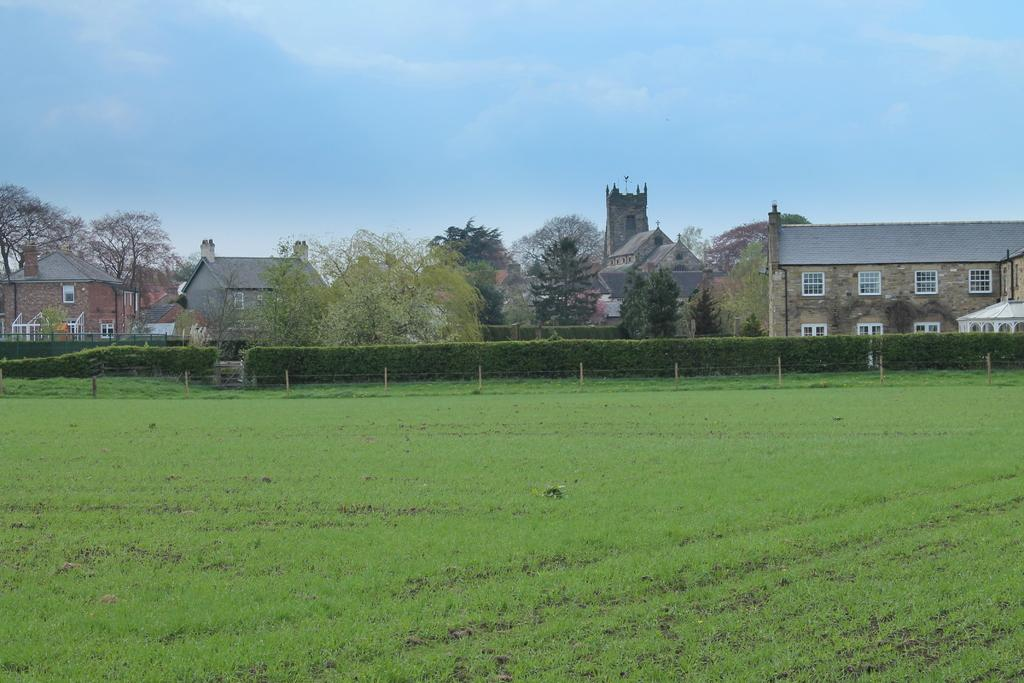What type of vegetation can be seen in the image? There is grass and plants in the image. What structure is present in the image? There is a fence in the image. What type of man-made structures are visible in the image? There are buildings in the image. What other natural elements can be seen in the image? There are trees in the image. What is visible in the background of the image? The sky is visible in the background of the image. What type of fuel is being used by the governor in the image? There is no governor or fuel present in the image. What activity are the children participating in during recess in the image? There is no recess or children present in the image. 